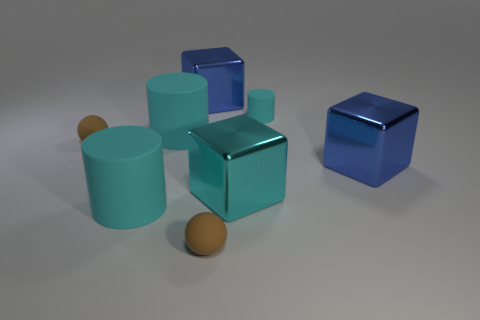Are any large yellow rubber things visible?
Make the answer very short. No. There is a big object right of the small matte cylinder; what color is it?
Give a very brief answer. Blue. What number of other objects are the same material as the cyan cube?
Make the answer very short. 2. What is the color of the thing that is right of the large cyan metallic thing and in front of the tiny cyan thing?
Offer a terse response. Blue. What number of things are either rubber cylinders on the left side of the large cyan shiny object or large cyan cylinders?
Make the answer very short. 2. How many other objects are the same color as the small cylinder?
Provide a succinct answer. 3. Are there the same number of large cyan metal objects that are in front of the small cyan thing and tiny cyan cylinders?
Your answer should be compact. Yes. There is a tiny brown sphere right of the large rubber cylinder in front of the cyan metal object; how many blue metallic blocks are on the left side of it?
Provide a short and direct response. 1. There is a cyan metallic block; does it have the same size as the cube on the left side of the big cyan cube?
Your answer should be very brief. Yes. How many small cylinders are there?
Your answer should be compact. 1. 